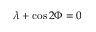<formula> <loc_0><loc_0><loc_500><loc_500>\lambda + \cos { 2 \Phi } = 0</formula> 